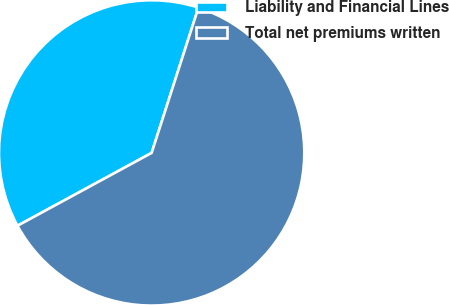Convert chart to OTSL. <chart><loc_0><loc_0><loc_500><loc_500><pie_chart><fcel>Liability and Financial Lines<fcel>Total net premiums written<nl><fcel>37.88%<fcel>62.12%<nl></chart> 